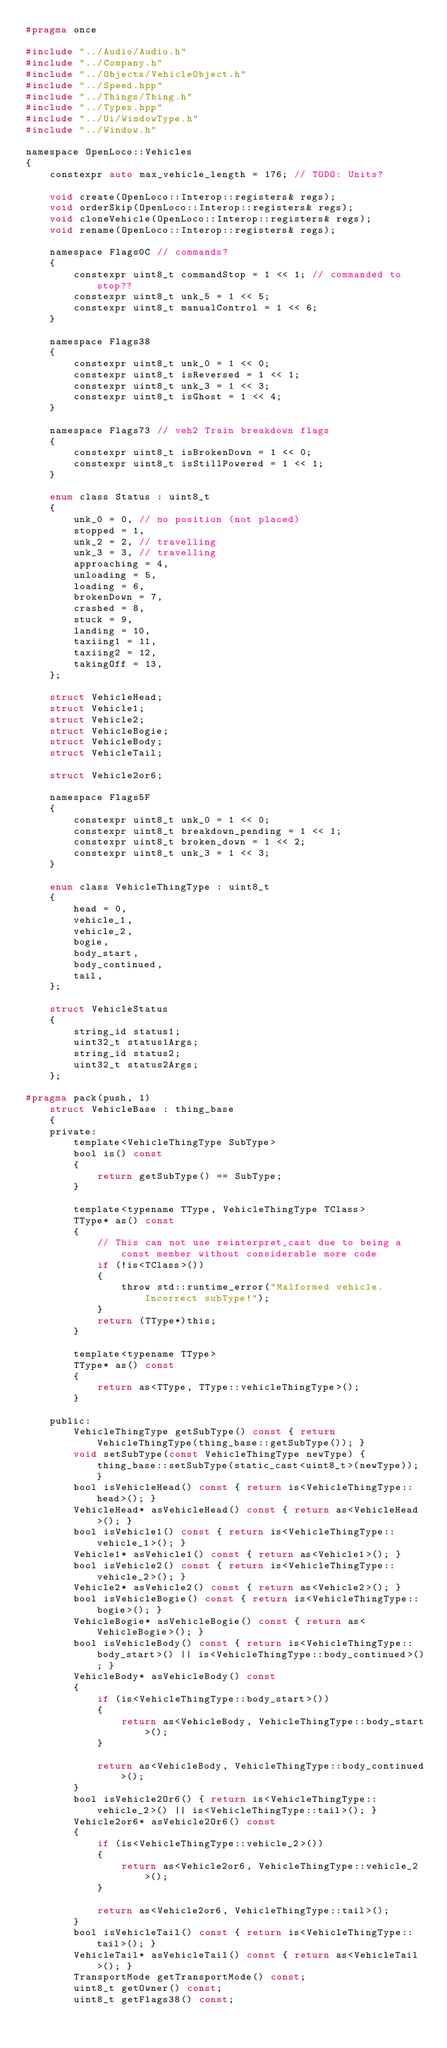<code> <loc_0><loc_0><loc_500><loc_500><_C_>#pragma once

#include "../Audio/Audio.h"
#include "../Company.h"
#include "../Objects/VehicleObject.h"
#include "../Speed.hpp"
#include "../Things/Thing.h"
#include "../Types.hpp"
#include "../Ui/WindowType.h"
#include "../Window.h"

namespace OpenLoco::Vehicles
{
    constexpr auto max_vehicle_length = 176; // TODO: Units?

    void create(OpenLoco::Interop::registers& regs);
    void orderSkip(OpenLoco::Interop::registers& regs);
    void cloneVehicle(OpenLoco::Interop::registers& regs);
    void rename(OpenLoco::Interop::registers& regs);

    namespace Flags0C // commands?
    {
        constexpr uint8_t commandStop = 1 << 1; // commanded to stop??
        constexpr uint8_t unk_5 = 1 << 5;
        constexpr uint8_t manualControl = 1 << 6;
    }

    namespace Flags38
    {
        constexpr uint8_t unk_0 = 1 << 0;
        constexpr uint8_t isReversed = 1 << 1;
        constexpr uint8_t unk_3 = 1 << 3;
        constexpr uint8_t isGhost = 1 << 4;
    }

    namespace Flags73 // veh2 Train breakdown flags
    {
        constexpr uint8_t isBrokenDown = 1 << 0;
        constexpr uint8_t isStillPowered = 1 << 1;
    }

    enum class Status : uint8_t
    {
        unk_0 = 0, // no position (not placed)
        stopped = 1,
        unk_2 = 2, // travelling
        unk_3 = 3, // travelling
        approaching = 4,
        unloading = 5,
        loading = 6,
        brokenDown = 7,
        crashed = 8,
        stuck = 9,
        landing = 10,
        taxiing1 = 11,
        taxiing2 = 12,
        takingOff = 13,
    };

    struct VehicleHead;
    struct Vehicle1;
    struct Vehicle2;
    struct VehicleBogie;
    struct VehicleBody;
    struct VehicleTail;

    struct Vehicle2or6;

    namespace Flags5F
    {
        constexpr uint8_t unk_0 = 1 << 0;
        constexpr uint8_t breakdown_pending = 1 << 1;
        constexpr uint8_t broken_down = 1 << 2;
        constexpr uint8_t unk_3 = 1 << 3;
    }

    enum class VehicleThingType : uint8_t
    {
        head = 0,
        vehicle_1,
        vehicle_2,
        bogie,
        body_start,
        body_continued,
        tail,
    };

    struct VehicleStatus
    {
        string_id status1;
        uint32_t status1Args;
        string_id status2;
        uint32_t status2Args;
    };

#pragma pack(push, 1)
    struct VehicleBase : thing_base
    {
    private:
        template<VehicleThingType SubType>
        bool is() const
        {
            return getSubType() == SubType;
        }

        template<typename TType, VehicleThingType TClass>
        TType* as() const
        {
            // This can not use reinterpret_cast due to being a const member without considerable more code
            if (!is<TClass>())
            {
                throw std::runtime_error("Malformed vehicle. Incorrect subType!");
            }
            return (TType*)this;
        }

        template<typename TType>
        TType* as() const
        {
            return as<TType, TType::vehicleThingType>();
        }

    public:
        VehicleThingType getSubType() const { return VehicleThingType(thing_base::getSubType()); }
        void setSubType(const VehicleThingType newType) { thing_base::setSubType(static_cast<uint8_t>(newType)); }
        bool isVehicleHead() const { return is<VehicleThingType::head>(); }
        VehicleHead* asVehicleHead() const { return as<VehicleHead>(); }
        bool isVehicle1() const { return is<VehicleThingType::vehicle_1>(); }
        Vehicle1* asVehicle1() const { return as<Vehicle1>(); }
        bool isVehicle2() const { return is<VehicleThingType::vehicle_2>(); }
        Vehicle2* asVehicle2() const { return as<Vehicle2>(); }
        bool isVehicleBogie() const { return is<VehicleThingType::bogie>(); }
        VehicleBogie* asVehicleBogie() const { return as<VehicleBogie>(); }
        bool isVehicleBody() const { return is<VehicleThingType::body_start>() || is<VehicleThingType::body_continued>(); }
        VehicleBody* asVehicleBody() const
        {
            if (is<VehicleThingType::body_start>())
            {
                return as<VehicleBody, VehicleThingType::body_start>();
            }

            return as<VehicleBody, VehicleThingType::body_continued>();
        }
        bool isVehicle2Or6() { return is<VehicleThingType::vehicle_2>() || is<VehicleThingType::tail>(); }
        Vehicle2or6* asVehicle2Or6() const
        {
            if (is<VehicleThingType::vehicle_2>())
            {
                return as<Vehicle2or6, VehicleThingType::vehicle_2>();
            }

            return as<Vehicle2or6, VehicleThingType::tail>();
        }
        bool isVehicleTail() const { return is<VehicleThingType::tail>(); }
        VehicleTail* asVehicleTail() const { return as<VehicleTail>(); }
        TransportMode getTransportMode() const;
        uint8_t getOwner() const;
        uint8_t getFlags38() const;</code> 